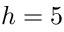Convert formula to latex. <formula><loc_0><loc_0><loc_500><loc_500>h = 5</formula> 